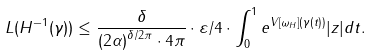<formula> <loc_0><loc_0><loc_500><loc_500>L ( H ^ { - 1 } ( \gamma ) ) \leq \frac { \delta } { { ( 2 \alpha ) } ^ { \delta / 2 \pi } \cdot 4 \pi } \cdot \varepsilon / 4 \cdot \int _ { 0 } ^ { 1 } e ^ { V [ \omega _ { H } ] ( \gamma ( t ) ) } | z | d t .</formula> 